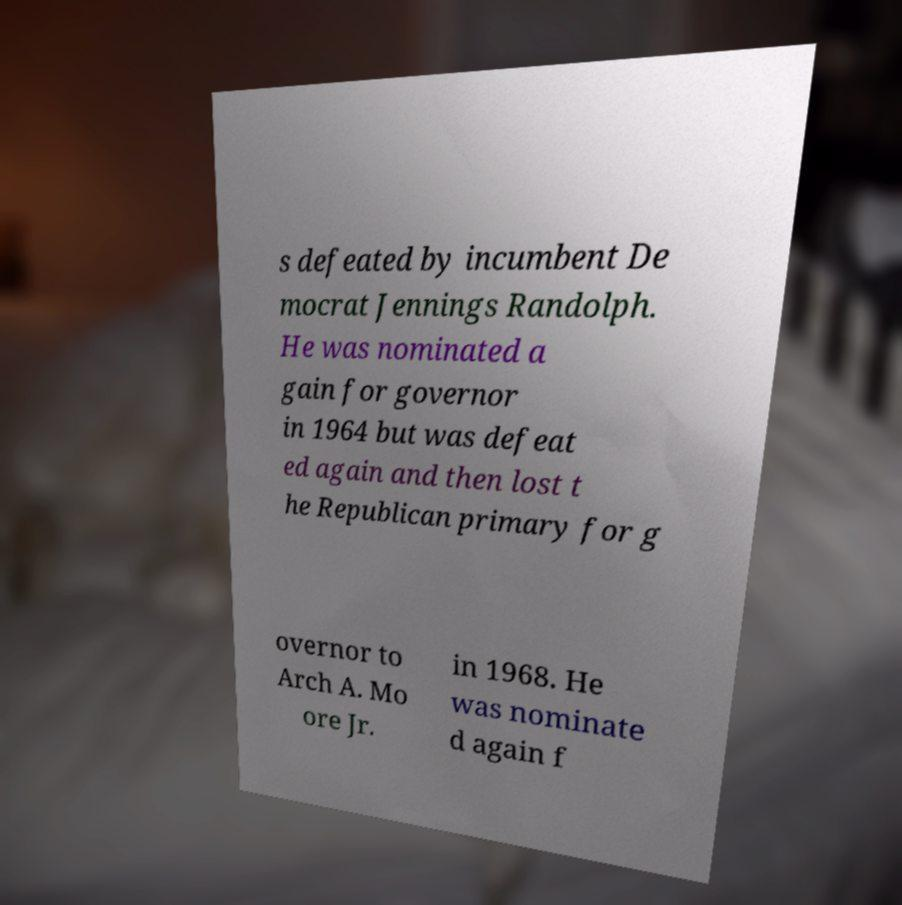Please read and relay the text visible in this image. What does it say? s defeated by incumbent De mocrat Jennings Randolph. He was nominated a gain for governor in 1964 but was defeat ed again and then lost t he Republican primary for g overnor to Arch A. Mo ore Jr. in 1968. He was nominate d again f 